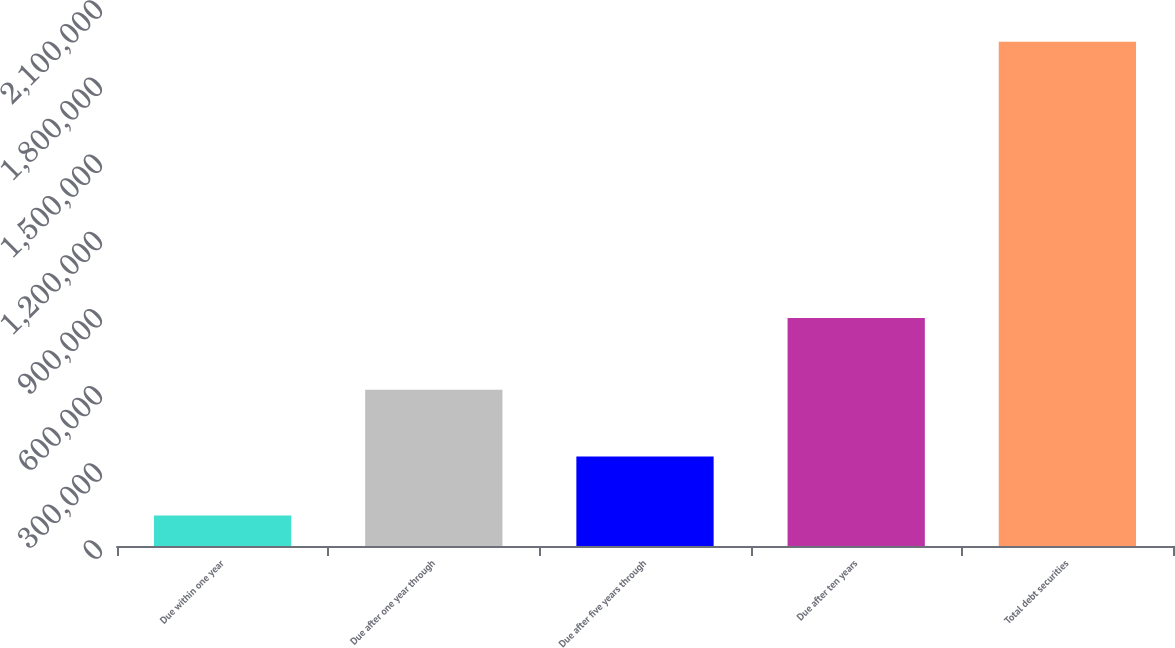Convert chart. <chart><loc_0><loc_0><loc_500><loc_500><bar_chart><fcel>Due within one year<fcel>Due after one year through<fcel>Due after five years through<fcel>Due after ten years<fcel>Total debt securities<nl><fcel>118393<fcel>607343<fcel>347908<fcel>886944<fcel>1.96059e+06<nl></chart> 